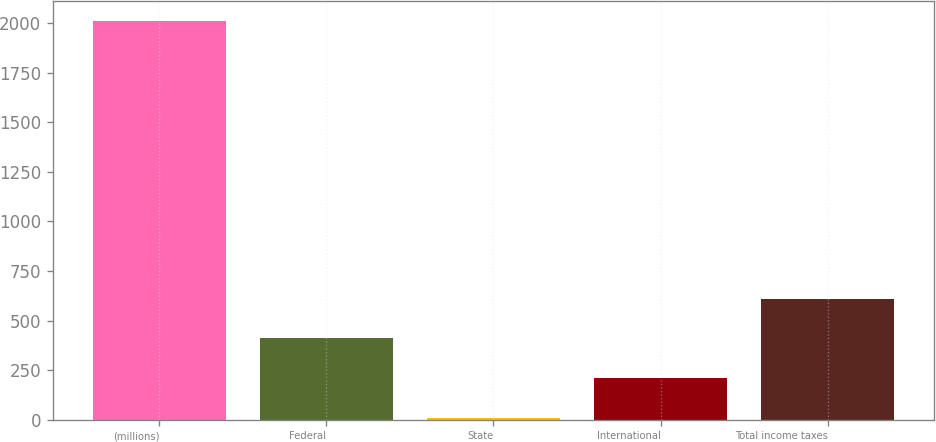Convert chart. <chart><loc_0><loc_0><loc_500><loc_500><bar_chart><fcel>(millions)<fcel>Federal<fcel>State<fcel>International<fcel>Total income taxes<nl><fcel>2012<fcel>410.48<fcel>10.1<fcel>210.29<fcel>610.67<nl></chart> 